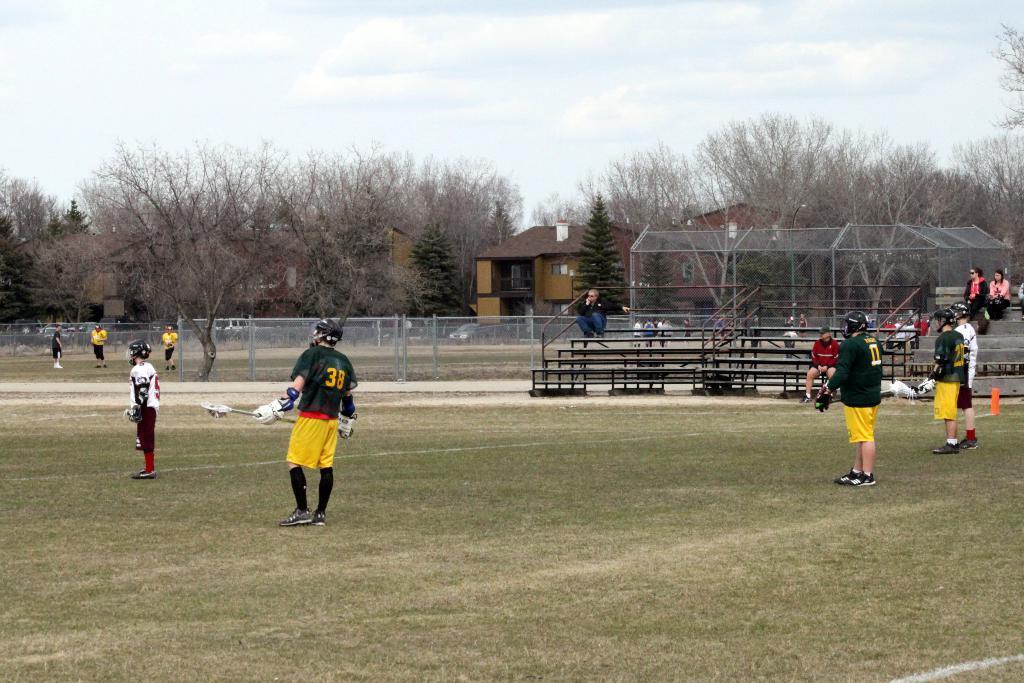Please provide a concise description of this image. This image is taken at the playground. In this image there are many players standing on the ground and holding their objects. On the right side of the image there are a few people sitting on their chairs. In the background of the image there are trees, house and sky. 